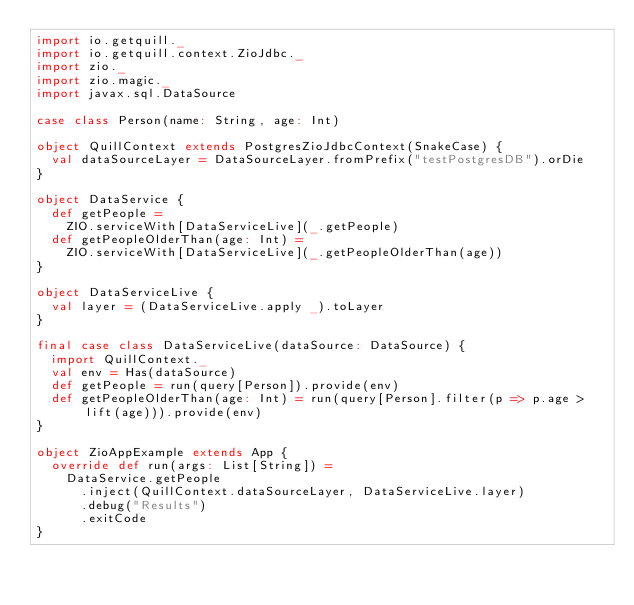Convert code to text. <code><loc_0><loc_0><loc_500><loc_500><_Scala_>import io.getquill._
import io.getquill.context.ZioJdbc._
import zio._
import zio.magic._
import javax.sql.DataSource

case class Person(name: String, age: Int)

object QuillContext extends PostgresZioJdbcContext(SnakeCase) {
  val dataSourceLayer = DataSourceLayer.fromPrefix("testPostgresDB").orDie
}

object DataService {
  def getPeople =
    ZIO.serviceWith[DataServiceLive](_.getPeople)
  def getPeopleOlderThan(age: Int) =
    ZIO.serviceWith[DataServiceLive](_.getPeopleOlderThan(age))
}

object DataServiceLive {
  val layer = (DataServiceLive.apply _).toLayer
}

final case class DataServiceLive(dataSource: DataSource) {
  import QuillContext._
  val env = Has(dataSource)
  def getPeople = run(query[Person]).provide(env)
  def getPeopleOlderThan(age: Int) = run(query[Person].filter(p => p.age > lift(age))).provide(env)
}

object ZioAppExample extends App {
  override def run(args: List[String]) =
    DataService.getPeople
      .inject(QuillContext.dataSourceLayer, DataServiceLive.layer)
      .debug("Results")
      .exitCode
}
</code> 